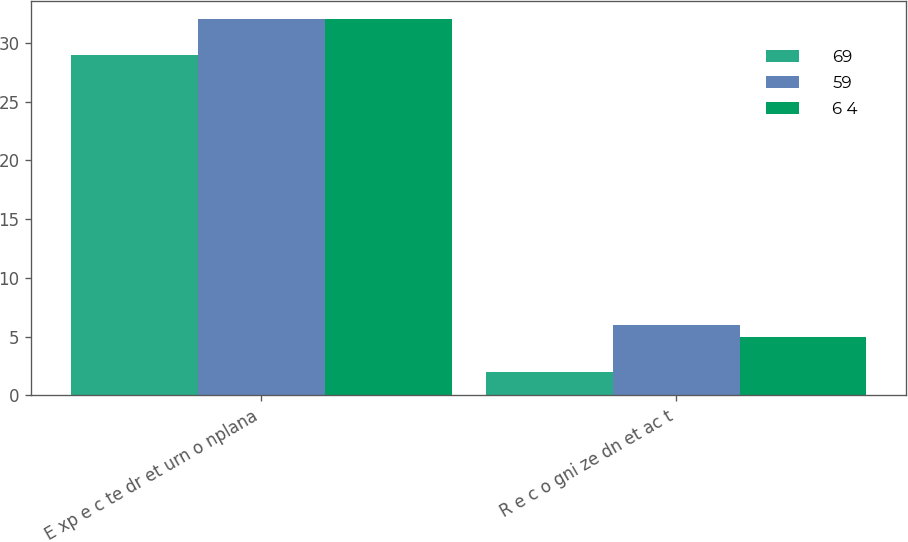Convert chart. <chart><loc_0><loc_0><loc_500><loc_500><stacked_bar_chart><ecel><fcel>E xp e c te dr et urn o nplana<fcel>R e c o gni ze dn et ac t<nl><fcel>69<fcel>29<fcel>2<nl><fcel>59<fcel>32<fcel>6<nl><fcel>6 4<fcel>32<fcel>5<nl></chart> 